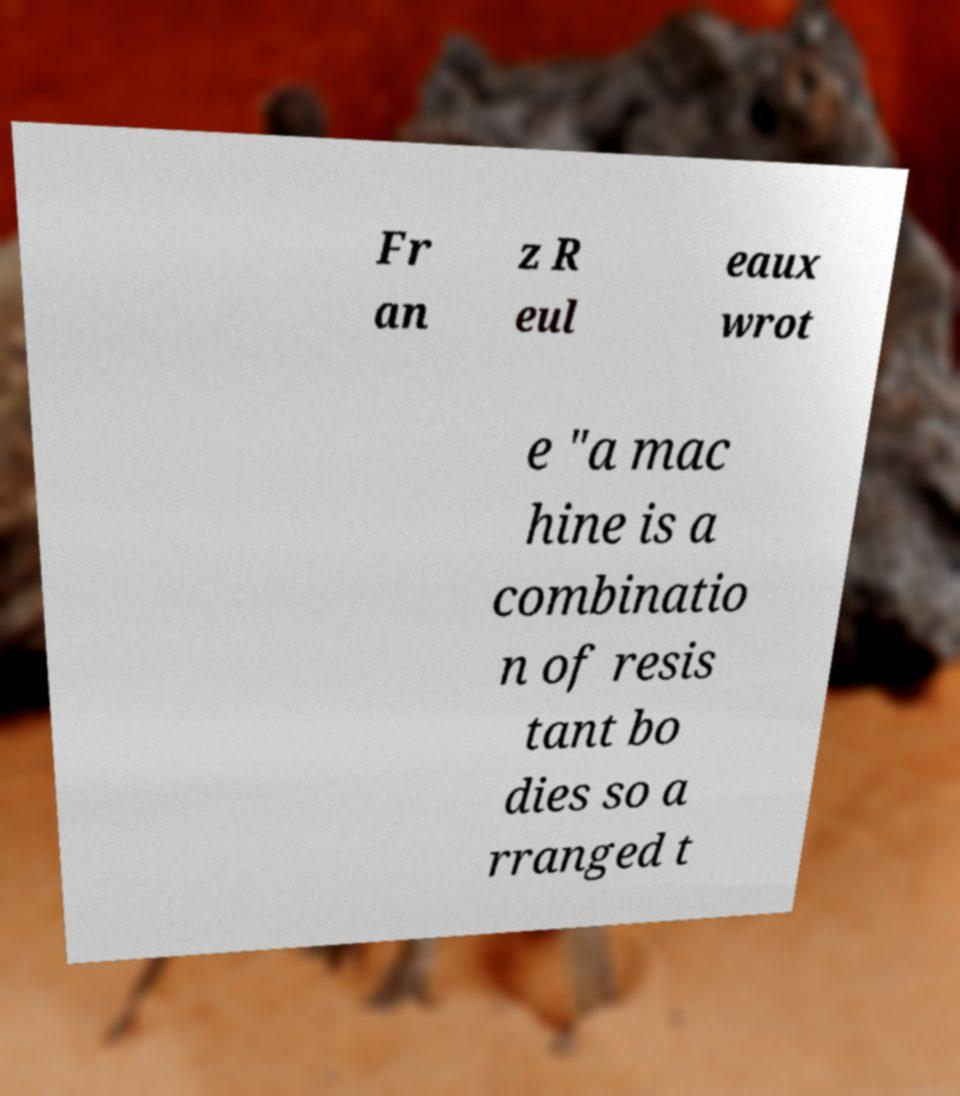I need the written content from this picture converted into text. Can you do that? Fr an z R eul eaux wrot e "a mac hine is a combinatio n of resis tant bo dies so a rranged t 